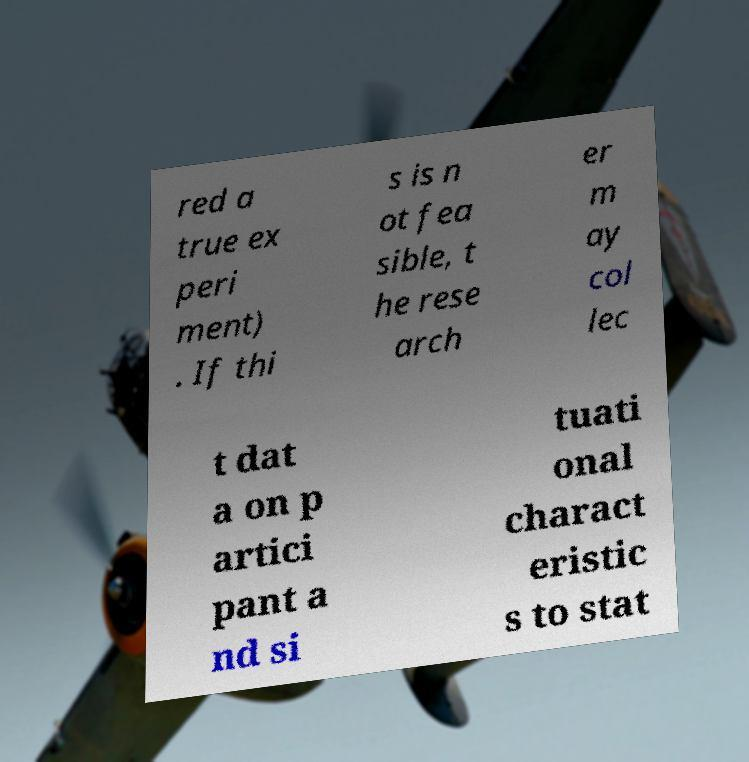Could you assist in decoding the text presented in this image and type it out clearly? red a true ex peri ment) . If thi s is n ot fea sible, t he rese arch er m ay col lec t dat a on p artici pant a nd si tuati onal charact eristic s to stat 